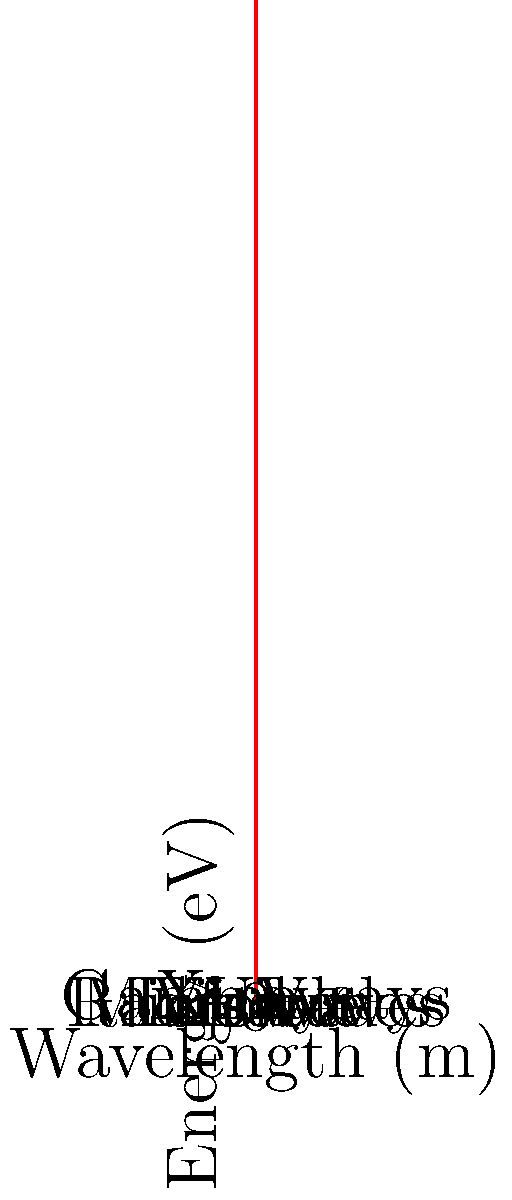In the context of mobile device sensors and accessibility features for visually impaired users, which part of the electromagnetic spectrum is most commonly utilized by proximity sensors in smartphones? How does this relate to the energy levels shown in the graph? To answer this question, let's break it down step-by-step:

1. Proximity sensors in smartphones typically use infrared (IR) light.

2. Looking at the graph, we can see that the electromagnetic spectrum is represented with wavelength on the x-axis and energy on the y-axis.

3. The relationship between energy (E) and wavelength (λ) is given by the equation:

   $$E = \frac{hc}{\lambda}$$

   where h is Planck's constant and c is the speed of light.

4. This relationship is represented by the hyperbolic curve on the graph, showing that as wavelength increases, energy decreases.

5. Infrared light is located in the lower-right portion of the graph, between visible light and microwaves.

6. Infrared light has longer wavelengths and lower energy compared to visible light, which makes it suitable for proximity sensors because:
   a) It's invisible to the human eye, preventing interference with the user experience.
   b) It's safe for human exposure at the low power levels used in mobile devices.
   c) It can be easily detected by low-cost sensors.

7. For visually impaired users, proximity sensors using infrared light can be particularly useful in features like:
   a) Automatically turning off the screen when the phone is held to the ear during a call.
   b) Gesture recognition for non-visual interface control.
   c) Obstacle detection in accessibility apps.

8. The lower energy of infrared light (compared to visible light or higher energy radiation) means that these sensors can operate with low power consumption, which is crucial for mobile device battery life.
Answer: Infrared (IR) light 